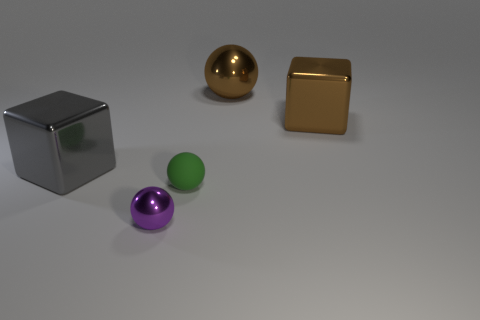Add 3 big gray metal cubes. How many objects exist? 8 Subtract all cubes. How many objects are left? 3 Subtract all large brown metal blocks. Subtract all big brown shiny cubes. How many objects are left? 3 Add 3 small purple metallic spheres. How many small purple metallic spheres are left? 4 Add 5 large brown metal balls. How many large brown metal balls exist? 6 Subtract 0 purple cylinders. How many objects are left? 5 